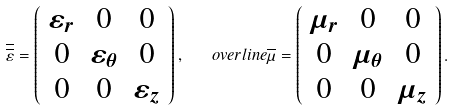Convert formula to latex. <formula><loc_0><loc_0><loc_500><loc_500>\overline { \overline { \varepsilon } } = \left ( \begin{array} { c c c } \varepsilon _ { r } & 0 & 0 \\ 0 & \varepsilon _ { \theta } & 0 \\ 0 & 0 & \varepsilon _ { z } \end{array} \right ) , \quad o v e r l i n e { \overline { \mu } } = \left ( \begin{array} { c c c } \mu _ { r } & 0 & 0 \\ 0 & \mu _ { \theta } & 0 \\ 0 & 0 & \mu _ { z } \end{array} \right ) .</formula> 